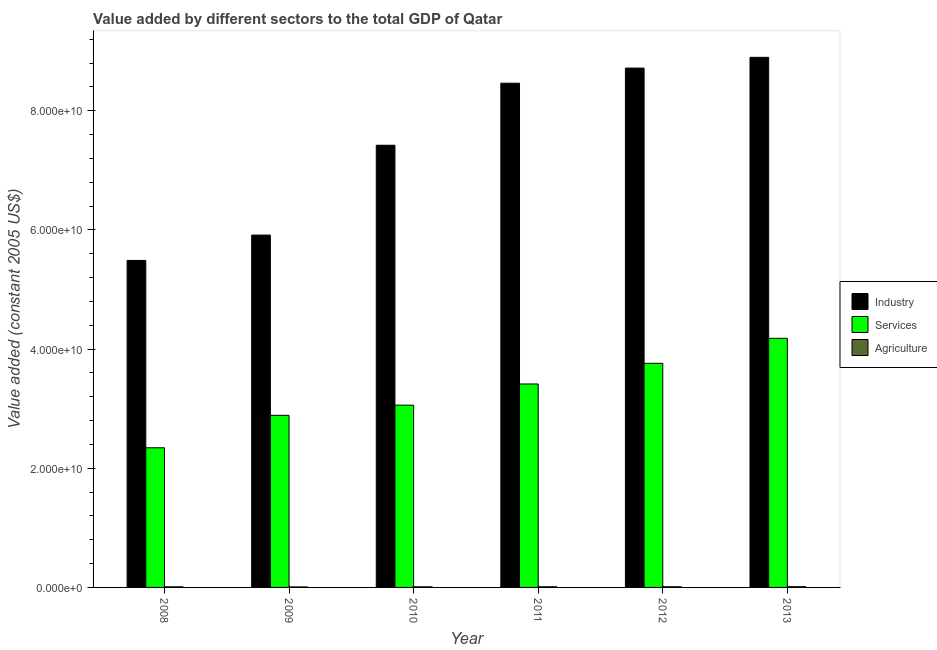How many different coloured bars are there?
Give a very brief answer. 3. How many groups of bars are there?
Provide a succinct answer. 6. Are the number of bars per tick equal to the number of legend labels?
Make the answer very short. Yes. In how many cases, is the number of bars for a given year not equal to the number of legend labels?
Your answer should be very brief. 0. What is the value added by services in 2010?
Offer a terse response. 3.06e+1. Across all years, what is the maximum value added by industrial sector?
Your response must be concise. 8.90e+1. Across all years, what is the minimum value added by agricultural sector?
Ensure brevity in your answer.  8.62e+07. In which year was the value added by agricultural sector minimum?
Your response must be concise. 2009. What is the total value added by agricultural sector in the graph?
Provide a succinct answer. 6.35e+08. What is the difference between the value added by agricultural sector in 2010 and that in 2011?
Ensure brevity in your answer.  -5.54e+06. What is the difference between the value added by services in 2013 and the value added by agricultural sector in 2009?
Offer a very short reply. 1.29e+1. What is the average value added by services per year?
Keep it short and to the point. 3.27e+1. In the year 2009, what is the difference between the value added by services and value added by industrial sector?
Provide a short and direct response. 0. What is the ratio of the value added by services in 2011 to that in 2012?
Your response must be concise. 0.91. What is the difference between the highest and the second highest value added by industrial sector?
Offer a very short reply. 1.81e+09. What is the difference between the highest and the lowest value added by industrial sector?
Keep it short and to the point. 3.41e+1. In how many years, is the value added by agricultural sector greater than the average value added by agricultural sector taken over all years?
Your answer should be very brief. 3. Is the sum of the value added by services in 2009 and 2010 greater than the maximum value added by industrial sector across all years?
Make the answer very short. Yes. What does the 2nd bar from the left in 2008 represents?
Your answer should be very brief. Services. What does the 3rd bar from the right in 2010 represents?
Your answer should be compact. Industry. Are all the bars in the graph horizontal?
Your answer should be very brief. No. What is the difference between two consecutive major ticks on the Y-axis?
Your answer should be very brief. 2.00e+1. Does the graph contain any zero values?
Ensure brevity in your answer.  No. Does the graph contain grids?
Your answer should be very brief. No. How are the legend labels stacked?
Offer a very short reply. Vertical. What is the title of the graph?
Offer a very short reply. Value added by different sectors to the total GDP of Qatar. What is the label or title of the Y-axis?
Ensure brevity in your answer.  Value added (constant 2005 US$). What is the Value added (constant 2005 US$) of Industry in 2008?
Provide a short and direct response. 5.49e+1. What is the Value added (constant 2005 US$) in Services in 2008?
Keep it short and to the point. 2.34e+1. What is the Value added (constant 2005 US$) in Agriculture in 2008?
Keep it short and to the point. 1.04e+08. What is the Value added (constant 2005 US$) in Industry in 2009?
Keep it short and to the point. 5.91e+1. What is the Value added (constant 2005 US$) of Services in 2009?
Provide a short and direct response. 2.89e+1. What is the Value added (constant 2005 US$) of Agriculture in 2009?
Your response must be concise. 8.62e+07. What is the Value added (constant 2005 US$) of Industry in 2010?
Your answer should be very brief. 7.42e+1. What is the Value added (constant 2005 US$) of Services in 2010?
Offer a terse response. 3.06e+1. What is the Value added (constant 2005 US$) in Agriculture in 2010?
Provide a succinct answer. 1.03e+08. What is the Value added (constant 2005 US$) in Industry in 2011?
Provide a succinct answer. 8.46e+1. What is the Value added (constant 2005 US$) in Services in 2011?
Give a very brief answer. 3.41e+1. What is the Value added (constant 2005 US$) of Agriculture in 2011?
Provide a short and direct response. 1.08e+08. What is the Value added (constant 2005 US$) in Industry in 2012?
Provide a short and direct response. 8.72e+1. What is the Value added (constant 2005 US$) in Services in 2012?
Make the answer very short. 3.76e+1. What is the Value added (constant 2005 US$) of Agriculture in 2012?
Ensure brevity in your answer.  1.13e+08. What is the Value added (constant 2005 US$) in Industry in 2013?
Your answer should be compact. 8.90e+1. What is the Value added (constant 2005 US$) in Services in 2013?
Give a very brief answer. 4.18e+1. What is the Value added (constant 2005 US$) of Agriculture in 2013?
Give a very brief answer. 1.20e+08. Across all years, what is the maximum Value added (constant 2005 US$) in Industry?
Give a very brief answer. 8.90e+1. Across all years, what is the maximum Value added (constant 2005 US$) of Services?
Your answer should be very brief. 4.18e+1. Across all years, what is the maximum Value added (constant 2005 US$) of Agriculture?
Give a very brief answer. 1.20e+08. Across all years, what is the minimum Value added (constant 2005 US$) of Industry?
Your answer should be very brief. 5.49e+1. Across all years, what is the minimum Value added (constant 2005 US$) of Services?
Provide a short and direct response. 2.34e+1. Across all years, what is the minimum Value added (constant 2005 US$) in Agriculture?
Offer a very short reply. 8.62e+07. What is the total Value added (constant 2005 US$) in Industry in the graph?
Keep it short and to the point. 4.49e+11. What is the total Value added (constant 2005 US$) in Services in the graph?
Provide a short and direct response. 1.96e+11. What is the total Value added (constant 2005 US$) in Agriculture in the graph?
Provide a short and direct response. 6.35e+08. What is the difference between the Value added (constant 2005 US$) in Industry in 2008 and that in 2009?
Provide a succinct answer. -4.26e+09. What is the difference between the Value added (constant 2005 US$) of Services in 2008 and that in 2009?
Your response must be concise. -5.45e+09. What is the difference between the Value added (constant 2005 US$) of Agriculture in 2008 and that in 2009?
Provide a short and direct response. 1.76e+07. What is the difference between the Value added (constant 2005 US$) of Industry in 2008 and that in 2010?
Your answer should be very brief. -1.93e+1. What is the difference between the Value added (constant 2005 US$) of Services in 2008 and that in 2010?
Your answer should be very brief. -7.15e+09. What is the difference between the Value added (constant 2005 US$) in Agriculture in 2008 and that in 2010?
Provide a short and direct response. 8.65e+05. What is the difference between the Value added (constant 2005 US$) of Industry in 2008 and that in 2011?
Give a very brief answer. -2.97e+1. What is the difference between the Value added (constant 2005 US$) of Services in 2008 and that in 2011?
Your response must be concise. -1.07e+1. What is the difference between the Value added (constant 2005 US$) in Agriculture in 2008 and that in 2011?
Provide a short and direct response. -4.67e+06. What is the difference between the Value added (constant 2005 US$) in Industry in 2008 and that in 2012?
Ensure brevity in your answer.  -3.23e+1. What is the difference between the Value added (constant 2005 US$) of Services in 2008 and that in 2012?
Your answer should be very brief. -1.42e+1. What is the difference between the Value added (constant 2005 US$) in Agriculture in 2008 and that in 2012?
Provide a short and direct response. -9.69e+06. What is the difference between the Value added (constant 2005 US$) in Industry in 2008 and that in 2013?
Your response must be concise. -3.41e+1. What is the difference between the Value added (constant 2005 US$) of Services in 2008 and that in 2013?
Your answer should be compact. -1.84e+1. What is the difference between the Value added (constant 2005 US$) in Agriculture in 2008 and that in 2013?
Your response must be concise. -1.64e+07. What is the difference between the Value added (constant 2005 US$) in Industry in 2009 and that in 2010?
Your answer should be very brief. -1.51e+1. What is the difference between the Value added (constant 2005 US$) in Services in 2009 and that in 2010?
Keep it short and to the point. -1.71e+09. What is the difference between the Value added (constant 2005 US$) of Agriculture in 2009 and that in 2010?
Keep it short and to the point. -1.68e+07. What is the difference between the Value added (constant 2005 US$) of Industry in 2009 and that in 2011?
Make the answer very short. -2.55e+1. What is the difference between the Value added (constant 2005 US$) in Services in 2009 and that in 2011?
Offer a very short reply. -5.26e+09. What is the difference between the Value added (constant 2005 US$) in Agriculture in 2009 and that in 2011?
Keep it short and to the point. -2.23e+07. What is the difference between the Value added (constant 2005 US$) of Industry in 2009 and that in 2012?
Provide a succinct answer. -2.80e+1. What is the difference between the Value added (constant 2005 US$) in Services in 2009 and that in 2012?
Your response must be concise. -8.73e+09. What is the difference between the Value added (constant 2005 US$) of Agriculture in 2009 and that in 2012?
Ensure brevity in your answer.  -2.73e+07. What is the difference between the Value added (constant 2005 US$) in Industry in 2009 and that in 2013?
Your response must be concise. -2.98e+1. What is the difference between the Value added (constant 2005 US$) in Services in 2009 and that in 2013?
Your answer should be compact. -1.29e+1. What is the difference between the Value added (constant 2005 US$) of Agriculture in 2009 and that in 2013?
Your response must be concise. -3.41e+07. What is the difference between the Value added (constant 2005 US$) in Industry in 2010 and that in 2011?
Ensure brevity in your answer.  -1.04e+1. What is the difference between the Value added (constant 2005 US$) in Services in 2010 and that in 2011?
Your answer should be very brief. -3.55e+09. What is the difference between the Value added (constant 2005 US$) in Agriculture in 2010 and that in 2011?
Provide a short and direct response. -5.54e+06. What is the difference between the Value added (constant 2005 US$) in Industry in 2010 and that in 2012?
Offer a very short reply. -1.29e+1. What is the difference between the Value added (constant 2005 US$) in Services in 2010 and that in 2012?
Make the answer very short. -7.02e+09. What is the difference between the Value added (constant 2005 US$) in Agriculture in 2010 and that in 2012?
Make the answer very short. -1.06e+07. What is the difference between the Value added (constant 2005 US$) in Industry in 2010 and that in 2013?
Ensure brevity in your answer.  -1.48e+1. What is the difference between the Value added (constant 2005 US$) in Services in 2010 and that in 2013?
Your answer should be compact. -1.12e+1. What is the difference between the Value added (constant 2005 US$) of Agriculture in 2010 and that in 2013?
Offer a very short reply. -1.73e+07. What is the difference between the Value added (constant 2005 US$) in Industry in 2011 and that in 2012?
Make the answer very short. -2.54e+09. What is the difference between the Value added (constant 2005 US$) of Services in 2011 and that in 2012?
Your answer should be very brief. -3.47e+09. What is the difference between the Value added (constant 2005 US$) of Agriculture in 2011 and that in 2012?
Provide a succinct answer. -5.02e+06. What is the difference between the Value added (constant 2005 US$) in Industry in 2011 and that in 2013?
Keep it short and to the point. -4.34e+09. What is the difference between the Value added (constant 2005 US$) in Services in 2011 and that in 2013?
Offer a terse response. -7.67e+09. What is the difference between the Value added (constant 2005 US$) in Agriculture in 2011 and that in 2013?
Keep it short and to the point. -1.18e+07. What is the difference between the Value added (constant 2005 US$) of Industry in 2012 and that in 2013?
Your answer should be compact. -1.81e+09. What is the difference between the Value added (constant 2005 US$) in Services in 2012 and that in 2013?
Your response must be concise. -4.20e+09. What is the difference between the Value added (constant 2005 US$) of Agriculture in 2012 and that in 2013?
Ensure brevity in your answer.  -6.75e+06. What is the difference between the Value added (constant 2005 US$) of Industry in 2008 and the Value added (constant 2005 US$) of Services in 2009?
Your answer should be very brief. 2.60e+1. What is the difference between the Value added (constant 2005 US$) in Industry in 2008 and the Value added (constant 2005 US$) in Agriculture in 2009?
Ensure brevity in your answer.  5.48e+1. What is the difference between the Value added (constant 2005 US$) in Services in 2008 and the Value added (constant 2005 US$) in Agriculture in 2009?
Your answer should be compact. 2.34e+1. What is the difference between the Value added (constant 2005 US$) of Industry in 2008 and the Value added (constant 2005 US$) of Services in 2010?
Offer a terse response. 2.43e+1. What is the difference between the Value added (constant 2005 US$) of Industry in 2008 and the Value added (constant 2005 US$) of Agriculture in 2010?
Your answer should be very brief. 5.48e+1. What is the difference between the Value added (constant 2005 US$) in Services in 2008 and the Value added (constant 2005 US$) in Agriculture in 2010?
Your answer should be compact. 2.33e+1. What is the difference between the Value added (constant 2005 US$) in Industry in 2008 and the Value added (constant 2005 US$) in Services in 2011?
Give a very brief answer. 2.07e+1. What is the difference between the Value added (constant 2005 US$) of Industry in 2008 and the Value added (constant 2005 US$) of Agriculture in 2011?
Provide a short and direct response. 5.48e+1. What is the difference between the Value added (constant 2005 US$) of Services in 2008 and the Value added (constant 2005 US$) of Agriculture in 2011?
Offer a terse response. 2.33e+1. What is the difference between the Value added (constant 2005 US$) of Industry in 2008 and the Value added (constant 2005 US$) of Services in 2012?
Keep it short and to the point. 1.73e+1. What is the difference between the Value added (constant 2005 US$) of Industry in 2008 and the Value added (constant 2005 US$) of Agriculture in 2012?
Provide a short and direct response. 5.48e+1. What is the difference between the Value added (constant 2005 US$) in Services in 2008 and the Value added (constant 2005 US$) in Agriculture in 2012?
Offer a terse response. 2.33e+1. What is the difference between the Value added (constant 2005 US$) in Industry in 2008 and the Value added (constant 2005 US$) in Services in 2013?
Give a very brief answer. 1.31e+1. What is the difference between the Value added (constant 2005 US$) in Industry in 2008 and the Value added (constant 2005 US$) in Agriculture in 2013?
Your response must be concise. 5.48e+1. What is the difference between the Value added (constant 2005 US$) in Services in 2008 and the Value added (constant 2005 US$) in Agriculture in 2013?
Provide a succinct answer. 2.33e+1. What is the difference between the Value added (constant 2005 US$) of Industry in 2009 and the Value added (constant 2005 US$) of Services in 2010?
Your response must be concise. 2.85e+1. What is the difference between the Value added (constant 2005 US$) of Industry in 2009 and the Value added (constant 2005 US$) of Agriculture in 2010?
Provide a succinct answer. 5.90e+1. What is the difference between the Value added (constant 2005 US$) in Services in 2009 and the Value added (constant 2005 US$) in Agriculture in 2010?
Make the answer very short. 2.88e+1. What is the difference between the Value added (constant 2005 US$) in Industry in 2009 and the Value added (constant 2005 US$) in Services in 2011?
Give a very brief answer. 2.50e+1. What is the difference between the Value added (constant 2005 US$) of Industry in 2009 and the Value added (constant 2005 US$) of Agriculture in 2011?
Your answer should be compact. 5.90e+1. What is the difference between the Value added (constant 2005 US$) in Services in 2009 and the Value added (constant 2005 US$) in Agriculture in 2011?
Your answer should be very brief. 2.88e+1. What is the difference between the Value added (constant 2005 US$) in Industry in 2009 and the Value added (constant 2005 US$) in Services in 2012?
Provide a succinct answer. 2.15e+1. What is the difference between the Value added (constant 2005 US$) in Industry in 2009 and the Value added (constant 2005 US$) in Agriculture in 2012?
Your response must be concise. 5.90e+1. What is the difference between the Value added (constant 2005 US$) of Services in 2009 and the Value added (constant 2005 US$) of Agriculture in 2012?
Make the answer very short. 2.88e+1. What is the difference between the Value added (constant 2005 US$) of Industry in 2009 and the Value added (constant 2005 US$) of Services in 2013?
Offer a very short reply. 1.73e+1. What is the difference between the Value added (constant 2005 US$) in Industry in 2009 and the Value added (constant 2005 US$) in Agriculture in 2013?
Provide a succinct answer. 5.90e+1. What is the difference between the Value added (constant 2005 US$) of Services in 2009 and the Value added (constant 2005 US$) of Agriculture in 2013?
Ensure brevity in your answer.  2.88e+1. What is the difference between the Value added (constant 2005 US$) in Industry in 2010 and the Value added (constant 2005 US$) in Services in 2011?
Keep it short and to the point. 4.01e+1. What is the difference between the Value added (constant 2005 US$) of Industry in 2010 and the Value added (constant 2005 US$) of Agriculture in 2011?
Offer a terse response. 7.41e+1. What is the difference between the Value added (constant 2005 US$) in Services in 2010 and the Value added (constant 2005 US$) in Agriculture in 2011?
Make the answer very short. 3.05e+1. What is the difference between the Value added (constant 2005 US$) in Industry in 2010 and the Value added (constant 2005 US$) in Services in 2012?
Offer a very short reply. 3.66e+1. What is the difference between the Value added (constant 2005 US$) in Industry in 2010 and the Value added (constant 2005 US$) in Agriculture in 2012?
Your answer should be compact. 7.41e+1. What is the difference between the Value added (constant 2005 US$) in Services in 2010 and the Value added (constant 2005 US$) in Agriculture in 2012?
Provide a short and direct response. 3.05e+1. What is the difference between the Value added (constant 2005 US$) of Industry in 2010 and the Value added (constant 2005 US$) of Services in 2013?
Keep it short and to the point. 3.24e+1. What is the difference between the Value added (constant 2005 US$) in Industry in 2010 and the Value added (constant 2005 US$) in Agriculture in 2013?
Offer a very short reply. 7.41e+1. What is the difference between the Value added (constant 2005 US$) of Services in 2010 and the Value added (constant 2005 US$) of Agriculture in 2013?
Keep it short and to the point. 3.05e+1. What is the difference between the Value added (constant 2005 US$) in Industry in 2011 and the Value added (constant 2005 US$) in Services in 2012?
Give a very brief answer. 4.70e+1. What is the difference between the Value added (constant 2005 US$) in Industry in 2011 and the Value added (constant 2005 US$) in Agriculture in 2012?
Keep it short and to the point. 8.45e+1. What is the difference between the Value added (constant 2005 US$) in Services in 2011 and the Value added (constant 2005 US$) in Agriculture in 2012?
Ensure brevity in your answer.  3.40e+1. What is the difference between the Value added (constant 2005 US$) in Industry in 2011 and the Value added (constant 2005 US$) in Services in 2013?
Offer a terse response. 4.28e+1. What is the difference between the Value added (constant 2005 US$) in Industry in 2011 and the Value added (constant 2005 US$) in Agriculture in 2013?
Your response must be concise. 8.45e+1. What is the difference between the Value added (constant 2005 US$) in Services in 2011 and the Value added (constant 2005 US$) in Agriculture in 2013?
Provide a succinct answer. 3.40e+1. What is the difference between the Value added (constant 2005 US$) in Industry in 2012 and the Value added (constant 2005 US$) in Services in 2013?
Ensure brevity in your answer.  4.54e+1. What is the difference between the Value added (constant 2005 US$) in Industry in 2012 and the Value added (constant 2005 US$) in Agriculture in 2013?
Offer a very short reply. 8.70e+1. What is the difference between the Value added (constant 2005 US$) in Services in 2012 and the Value added (constant 2005 US$) in Agriculture in 2013?
Your response must be concise. 3.75e+1. What is the average Value added (constant 2005 US$) in Industry per year?
Ensure brevity in your answer.  7.48e+1. What is the average Value added (constant 2005 US$) of Services per year?
Make the answer very short. 3.27e+1. What is the average Value added (constant 2005 US$) of Agriculture per year?
Give a very brief answer. 1.06e+08. In the year 2008, what is the difference between the Value added (constant 2005 US$) of Industry and Value added (constant 2005 US$) of Services?
Offer a terse response. 3.14e+1. In the year 2008, what is the difference between the Value added (constant 2005 US$) of Industry and Value added (constant 2005 US$) of Agriculture?
Provide a short and direct response. 5.48e+1. In the year 2008, what is the difference between the Value added (constant 2005 US$) in Services and Value added (constant 2005 US$) in Agriculture?
Provide a succinct answer. 2.33e+1. In the year 2009, what is the difference between the Value added (constant 2005 US$) in Industry and Value added (constant 2005 US$) in Services?
Provide a succinct answer. 3.03e+1. In the year 2009, what is the difference between the Value added (constant 2005 US$) in Industry and Value added (constant 2005 US$) in Agriculture?
Your answer should be very brief. 5.91e+1. In the year 2009, what is the difference between the Value added (constant 2005 US$) in Services and Value added (constant 2005 US$) in Agriculture?
Give a very brief answer. 2.88e+1. In the year 2010, what is the difference between the Value added (constant 2005 US$) of Industry and Value added (constant 2005 US$) of Services?
Your answer should be very brief. 4.36e+1. In the year 2010, what is the difference between the Value added (constant 2005 US$) of Industry and Value added (constant 2005 US$) of Agriculture?
Keep it short and to the point. 7.41e+1. In the year 2010, what is the difference between the Value added (constant 2005 US$) in Services and Value added (constant 2005 US$) in Agriculture?
Your response must be concise. 3.05e+1. In the year 2011, what is the difference between the Value added (constant 2005 US$) in Industry and Value added (constant 2005 US$) in Services?
Your response must be concise. 5.05e+1. In the year 2011, what is the difference between the Value added (constant 2005 US$) of Industry and Value added (constant 2005 US$) of Agriculture?
Your answer should be compact. 8.45e+1. In the year 2011, what is the difference between the Value added (constant 2005 US$) in Services and Value added (constant 2005 US$) in Agriculture?
Provide a succinct answer. 3.40e+1. In the year 2012, what is the difference between the Value added (constant 2005 US$) of Industry and Value added (constant 2005 US$) of Services?
Your answer should be very brief. 4.96e+1. In the year 2012, what is the difference between the Value added (constant 2005 US$) in Industry and Value added (constant 2005 US$) in Agriculture?
Provide a short and direct response. 8.71e+1. In the year 2012, what is the difference between the Value added (constant 2005 US$) of Services and Value added (constant 2005 US$) of Agriculture?
Provide a succinct answer. 3.75e+1. In the year 2013, what is the difference between the Value added (constant 2005 US$) of Industry and Value added (constant 2005 US$) of Services?
Offer a terse response. 4.72e+1. In the year 2013, what is the difference between the Value added (constant 2005 US$) of Industry and Value added (constant 2005 US$) of Agriculture?
Provide a short and direct response. 8.88e+1. In the year 2013, what is the difference between the Value added (constant 2005 US$) in Services and Value added (constant 2005 US$) in Agriculture?
Your answer should be compact. 4.17e+1. What is the ratio of the Value added (constant 2005 US$) in Industry in 2008 to that in 2009?
Your answer should be compact. 0.93. What is the ratio of the Value added (constant 2005 US$) in Services in 2008 to that in 2009?
Provide a succinct answer. 0.81. What is the ratio of the Value added (constant 2005 US$) in Agriculture in 2008 to that in 2009?
Your answer should be very brief. 1.2. What is the ratio of the Value added (constant 2005 US$) of Industry in 2008 to that in 2010?
Offer a terse response. 0.74. What is the ratio of the Value added (constant 2005 US$) in Services in 2008 to that in 2010?
Make the answer very short. 0.77. What is the ratio of the Value added (constant 2005 US$) in Agriculture in 2008 to that in 2010?
Provide a short and direct response. 1.01. What is the ratio of the Value added (constant 2005 US$) of Industry in 2008 to that in 2011?
Offer a terse response. 0.65. What is the ratio of the Value added (constant 2005 US$) in Services in 2008 to that in 2011?
Keep it short and to the point. 0.69. What is the ratio of the Value added (constant 2005 US$) in Agriculture in 2008 to that in 2011?
Offer a very short reply. 0.96. What is the ratio of the Value added (constant 2005 US$) in Industry in 2008 to that in 2012?
Make the answer very short. 0.63. What is the ratio of the Value added (constant 2005 US$) of Services in 2008 to that in 2012?
Give a very brief answer. 0.62. What is the ratio of the Value added (constant 2005 US$) in Agriculture in 2008 to that in 2012?
Your answer should be very brief. 0.91. What is the ratio of the Value added (constant 2005 US$) of Industry in 2008 to that in 2013?
Provide a succinct answer. 0.62. What is the ratio of the Value added (constant 2005 US$) of Services in 2008 to that in 2013?
Offer a very short reply. 0.56. What is the ratio of the Value added (constant 2005 US$) in Agriculture in 2008 to that in 2013?
Your response must be concise. 0.86. What is the ratio of the Value added (constant 2005 US$) of Industry in 2009 to that in 2010?
Keep it short and to the point. 0.8. What is the ratio of the Value added (constant 2005 US$) of Services in 2009 to that in 2010?
Offer a very short reply. 0.94. What is the ratio of the Value added (constant 2005 US$) in Agriculture in 2009 to that in 2010?
Offer a very short reply. 0.84. What is the ratio of the Value added (constant 2005 US$) of Industry in 2009 to that in 2011?
Keep it short and to the point. 0.7. What is the ratio of the Value added (constant 2005 US$) of Services in 2009 to that in 2011?
Your answer should be very brief. 0.85. What is the ratio of the Value added (constant 2005 US$) of Agriculture in 2009 to that in 2011?
Provide a short and direct response. 0.79. What is the ratio of the Value added (constant 2005 US$) in Industry in 2009 to that in 2012?
Provide a succinct answer. 0.68. What is the ratio of the Value added (constant 2005 US$) in Services in 2009 to that in 2012?
Provide a succinct answer. 0.77. What is the ratio of the Value added (constant 2005 US$) in Agriculture in 2009 to that in 2012?
Provide a short and direct response. 0.76. What is the ratio of the Value added (constant 2005 US$) in Industry in 2009 to that in 2013?
Your response must be concise. 0.66. What is the ratio of the Value added (constant 2005 US$) of Services in 2009 to that in 2013?
Ensure brevity in your answer.  0.69. What is the ratio of the Value added (constant 2005 US$) of Agriculture in 2009 to that in 2013?
Your response must be concise. 0.72. What is the ratio of the Value added (constant 2005 US$) in Industry in 2010 to that in 2011?
Offer a very short reply. 0.88. What is the ratio of the Value added (constant 2005 US$) of Services in 2010 to that in 2011?
Provide a succinct answer. 0.9. What is the ratio of the Value added (constant 2005 US$) in Agriculture in 2010 to that in 2011?
Keep it short and to the point. 0.95. What is the ratio of the Value added (constant 2005 US$) in Industry in 2010 to that in 2012?
Ensure brevity in your answer.  0.85. What is the ratio of the Value added (constant 2005 US$) of Services in 2010 to that in 2012?
Your answer should be very brief. 0.81. What is the ratio of the Value added (constant 2005 US$) of Agriculture in 2010 to that in 2012?
Your answer should be compact. 0.91. What is the ratio of the Value added (constant 2005 US$) in Industry in 2010 to that in 2013?
Make the answer very short. 0.83. What is the ratio of the Value added (constant 2005 US$) in Services in 2010 to that in 2013?
Provide a succinct answer. 0.73. What is the ratio of the Value added (constant 2005 US$) of Agriculture in 2010 to that in 2013?
Provide a succinct answer. 0.86. What is the ratio of the Value added (constant 2005 US$) in Industry in 2011 to that in 2012?
Your response must be concise. 0.97. What is the ratio of the Value added (constant 2005 US$) in Services in 2011 to that in 2012?
Offer a terse response. 0.91. What is the ratio of the Value added (constant 2005 US$) of Agriculture in 2011 to that in 2012?
Keep it short and to the point. 0.96. What is the ratio of the Value added (constant 2005 US$) of Industry in 2011 to that in 2013?
Make the answer very short. 0.95. What is the ratio of the Value added (constant 2005 US$) of Services in 2011 to that in 2013?
Keep it short and to the point. 0.82. What is the ratio of the Value added (constant 2005 US$) in Agriculture in 2011 to that in 2013?
Provide a short and direct response. 0.9. What is the ratio of the Value added (constant 2005 US$) of Industry in 2012 to that in 2013?
Give a very brief answer. 0.98. What is the ratio of the Value added (constant 2005 US$) of Services in 2012 to that in 2013?
Ensure brevity in your answer.  0.9. What is the ratio of the Value added (constant 2005 US$) in Agriculture in 2012 to that in 2013?
Keep it short and to the point. 0.94. What is the difference between the highest and the second highest Value added (constant 2005 US$) of Industry?
Ensure brevity in your answer.  1.81e+09. What is the difference between the highest and the second highest Value added (constant 2005 US$) of Services?
Your answer should be compact. 4.20e+09. What is the difference between the highest and the second highest Value added (constant 2005 US$) of Agriculture?
Make the answer very short. 6.75e+06. What is the difference between the highest and the lowest Value added (constant 2005 US$) of Industry?
Your response must be concise. 3.41e+1. What is the difference between the highest and the lowest Value added (constant 2005 US$) in Services?
Make the answer very short. 1.84e+1. What is the difference between the highest and the lowest Value added (constant 2005 US$) in Agriculture?
Offer a very short reply. 3.41e+07. 